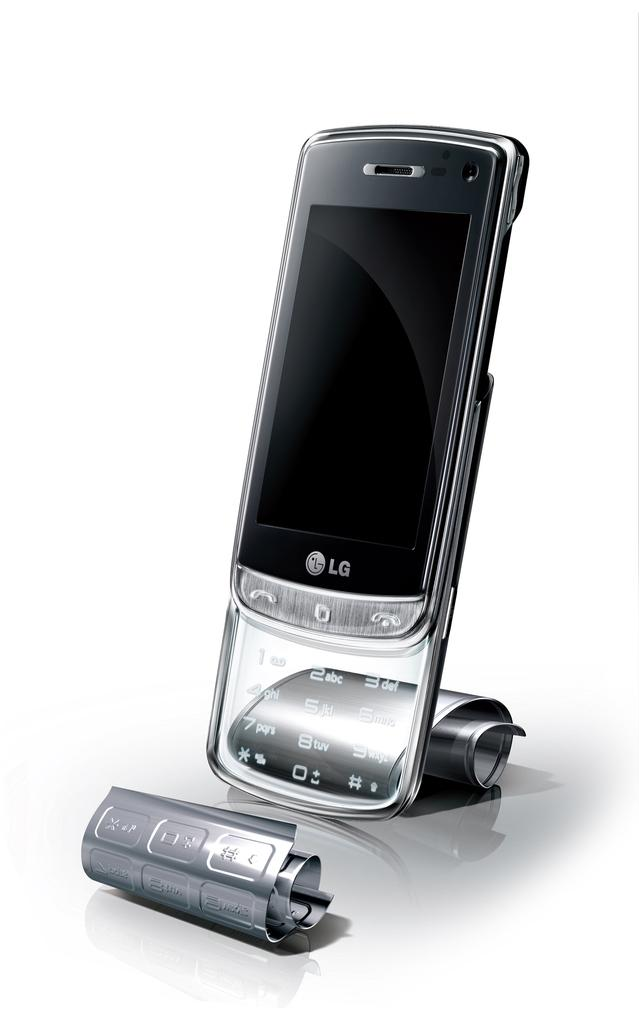<image>
Describe the image concisely. A black and clear, LG touch screen, slide phone is on display. 